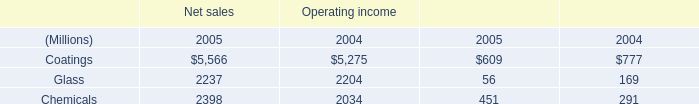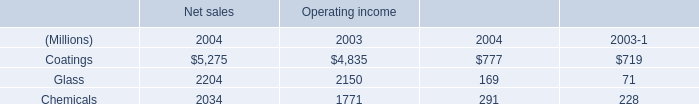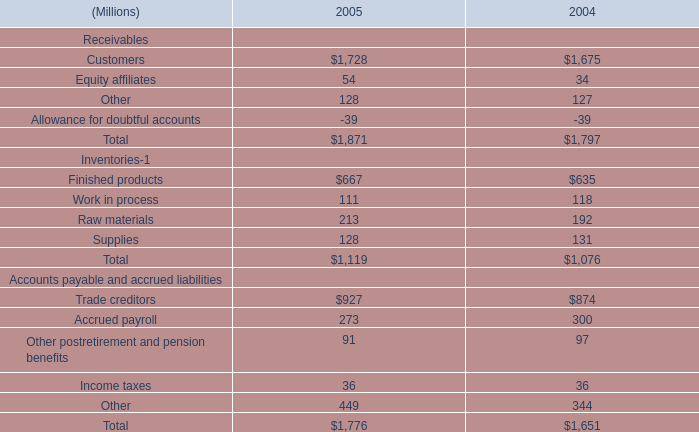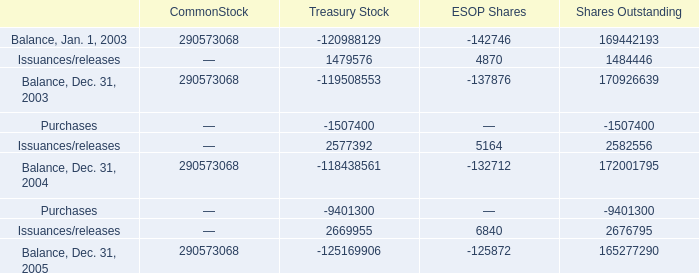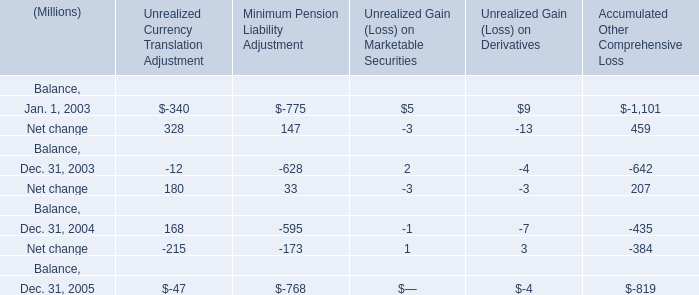What is the average amount of Glass of Operating income 2004, and Balance, Dec. 31, 2003 of Treasury Stock ? 
Computations: ((2204.0 + 290573068.0) / 2)
Answer: 145287636.0. 